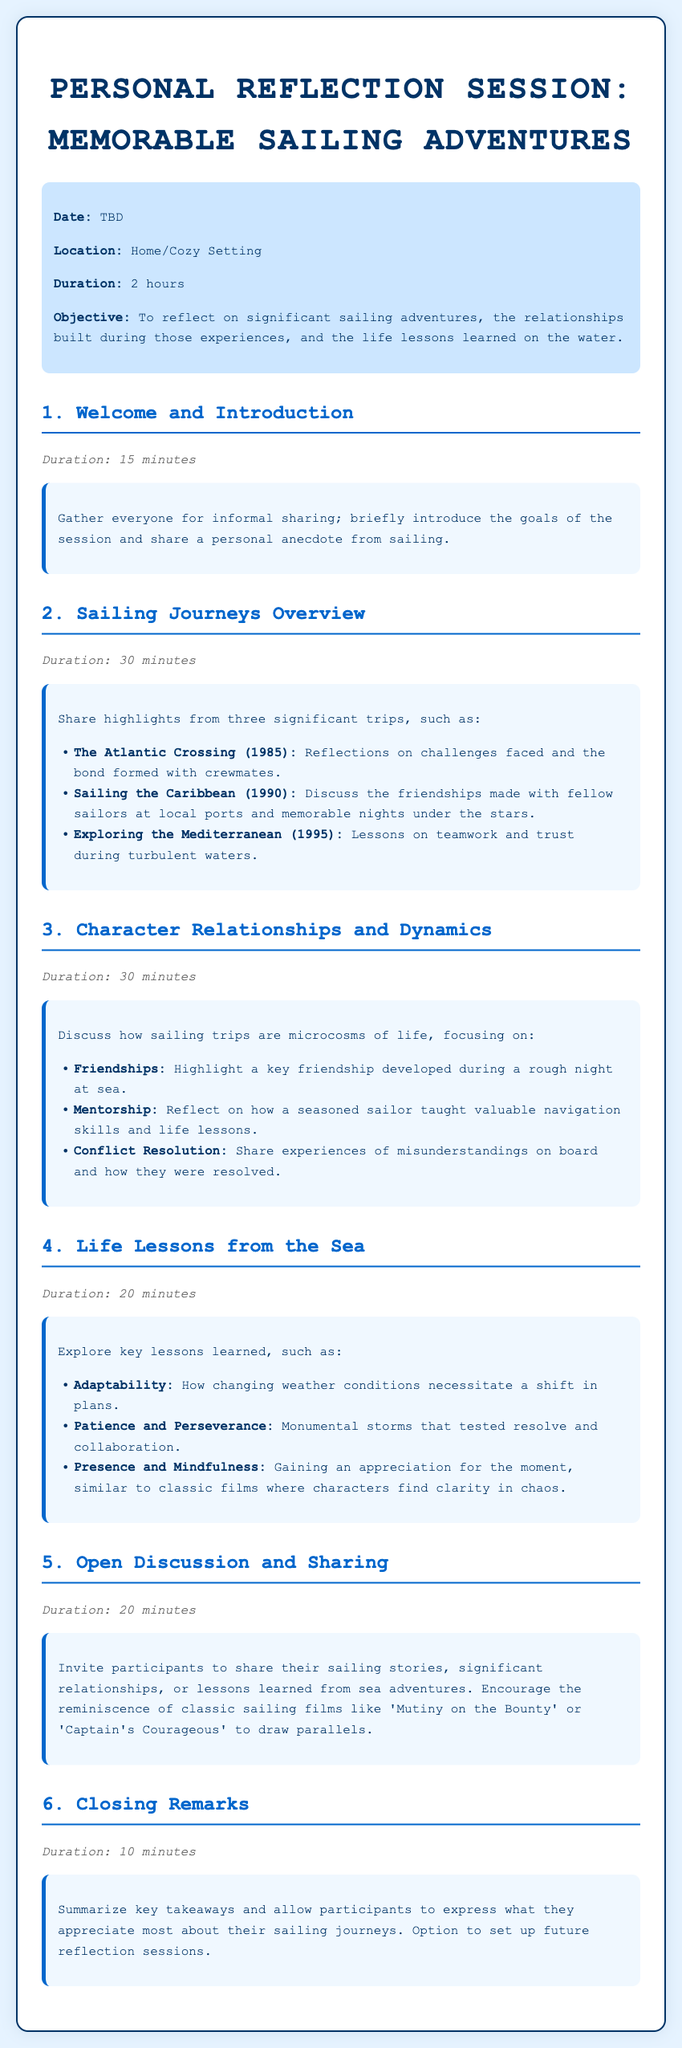what is the duration of the reflection session? The duration is specified in the meta section of the document as 2 hours.
Answer: 2 hours what are the key lessons learned from the sea? The document lists key lessons in section 4, which include adaptability, patience and perseverance, and presence and mindfulness.
Answer: Adaptability, patience and perseverance, presence and mindfulness how long is the welcome and introduction section? The duration for Section 1 is mentioned directly below the title in the document.
Answer: 15 minutes which sailing journey is discussed in 1990? The document specifies that the Caribbean sailing journey took place in 1990 in section 2.
Answer: Sailing the Caribbean what is the objective of the session? The objective is outlined in the meta section, highlighting the purpose of the reflection session.
Answer: To reflect on significant sailing adventures, relationships built, and life lessons learned name a classic sailing film mentioned for discussion. The document encourages discussion of classic films, specifically mentioning 'Mutiny on the Bounty.'
Answer: Mutiny on the Bounty how long is the section on character relationships and dynamics? The duration of section 3 is stated directly in the document.
Answer: 30 minutes what is a key friendship highlighted in section 3? The document refers to a key friendship developed during a rough night at sea in section 3.
Answer: A key friendship developed during a rough night at sea 